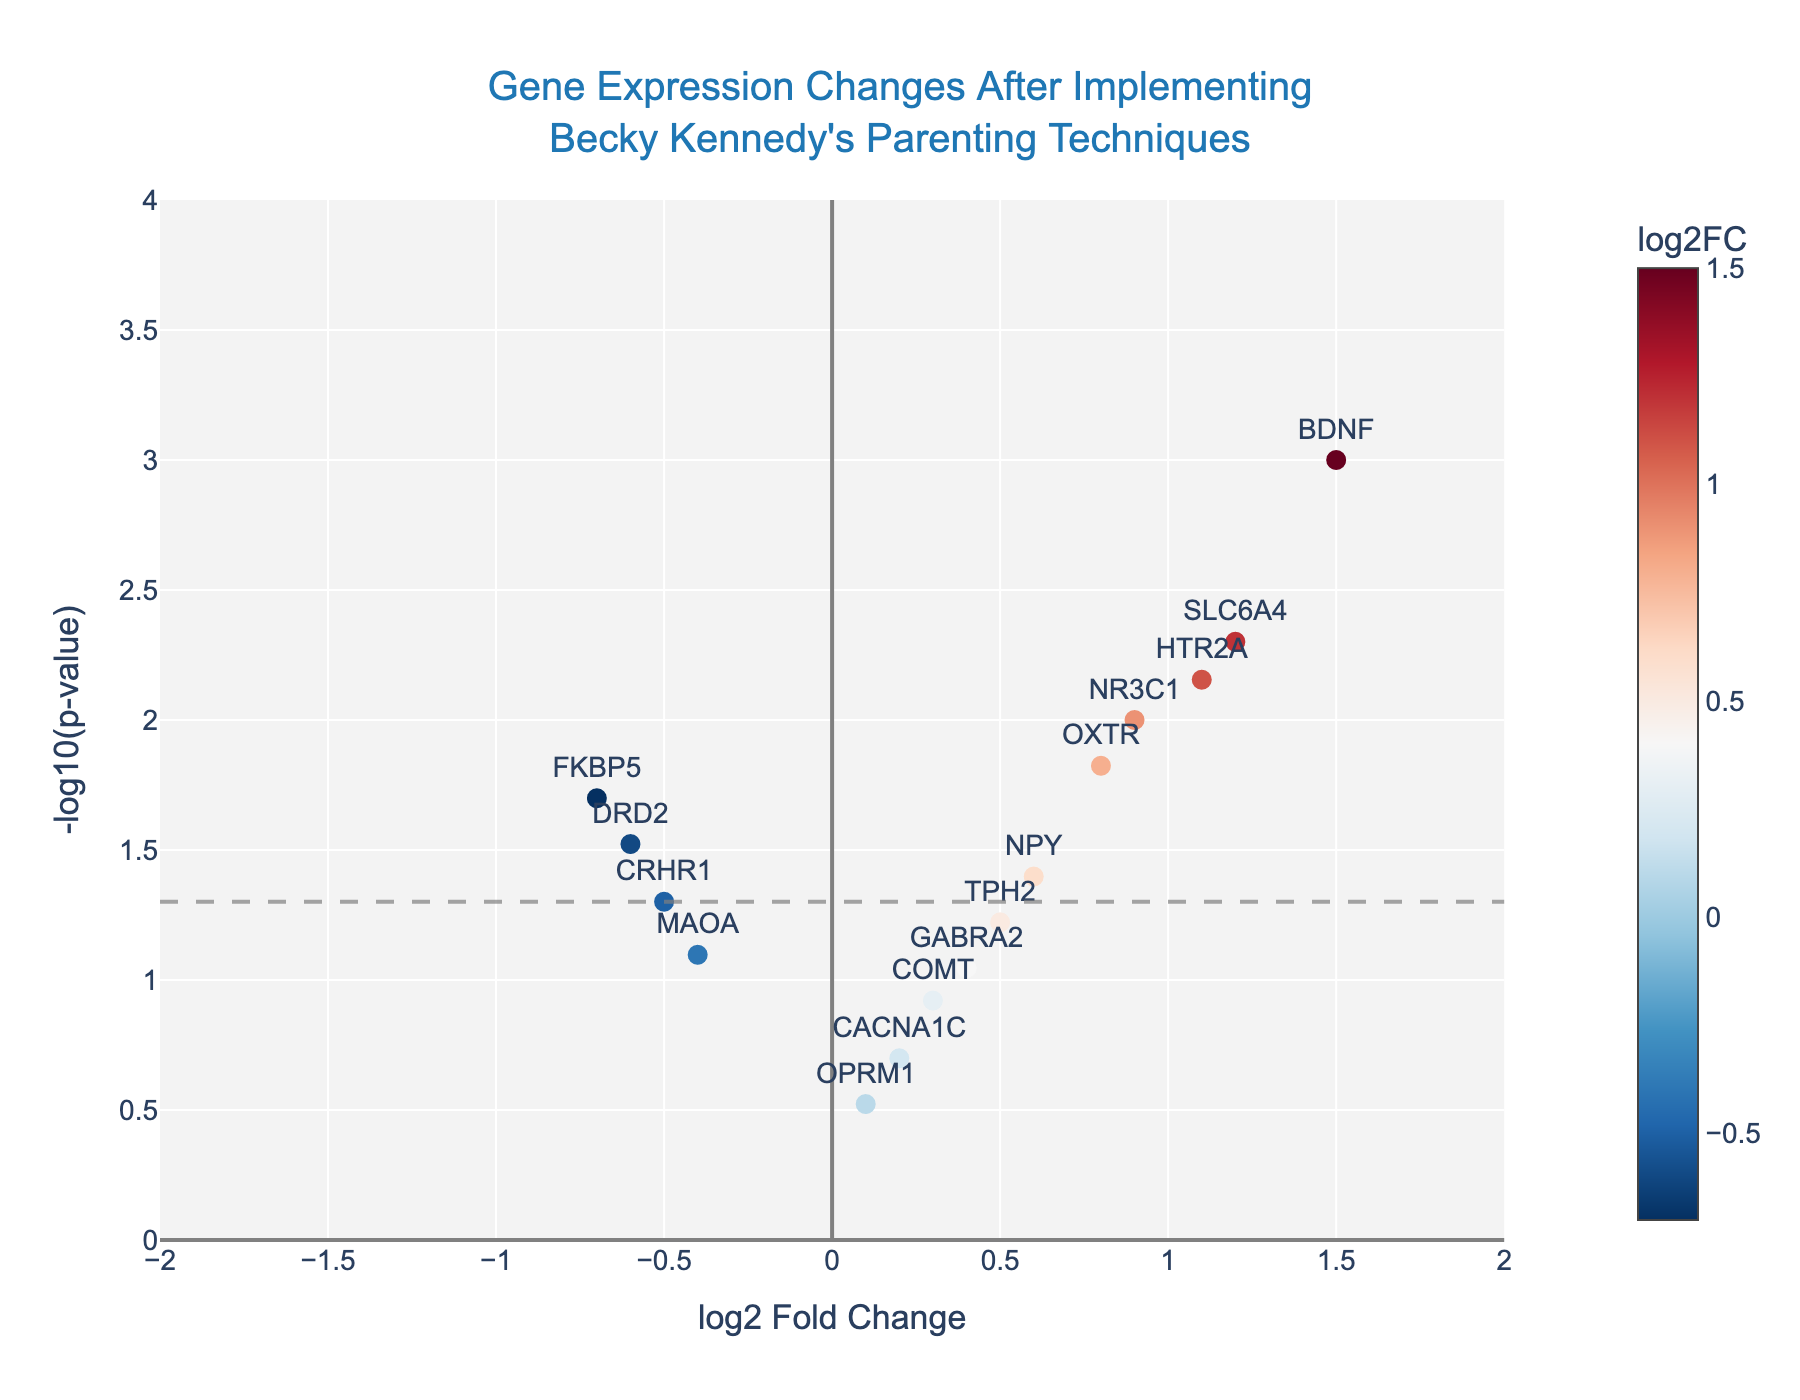what is the title of the plot? The title is displayed at the top center of the plot and typically summarizes the topic presented in the figure. Here, it reads "Gene Expression Changes After Implementing Becky's Parenting Techniques".
Answer: Gene Expression Changes After Implementing Becky's Parenting Techniques What do the colors of the markers represent? The color of the markers represents the log2 fold change (log2FC). This is indicated by a color bar on the right side of the plot, with a color scale transitioning from red to blue.
Answer: log2 fold change How many genes have a -log10(p-value) greater than 2? To determine the number of genes with a -log10(p-value) greater than 2, we count the markers above the y-axis value of 2 in the plot. These genes are BDNF, SLC6A4, NR3C1, and HTR2A.
Answer: 4 Which gene has the highest -log10(p-value)? Observing the plot, we locate the marker positioned at the highest y-axis value. The gene name next to this marker is BDNF.
Answer: BDNF Which gene has the most significant down-regulation? In this plot, down-regulation is shown by a negative log2 fold change. The gene farthest left is FKBP5.
Answer: FKBP5 Are there any genes with a log2 fold change between -0.5 and 0.5 and a -log10(p-value) greater than 1? To answer this, we identify markers within the range on the x-axis and above the y-axis value of 1. The relevant genes are TPH2, NPY, and NR3C1.
Answer: TPH2, NPY, NR3C1 Which genes have an insignificant p-value (p > 0.05)? Genes with p-values greater than 0.05 fall below the horizontal gray dashed line at y = -log10(0.05). These are TPH2, GABRA2, COMT, CACNA1C, MAOA, and OPRM1.
Answer: TPH2, GABRA2, COMT, CACNA1C, MAOA, OPRM1 What is the difference in log2 fold change between the genes BDNF and FKBP5? We subtract the log2 fold change of FKBP5 (-0.7) from that of BDNF (1.5). Therefore, the difference is 1.5 - (-0.7) = 2.2.
Answer: 2.2 Which gene has a p-value closest to 0.05, and is it up-regulated or down-regulated? The gene CRHR1 has a p-value of 0.05 and is below the gray dashed line, indicating it is down-regulated (negative log2 fold change).
Answer: CRHR1, down-regulated 